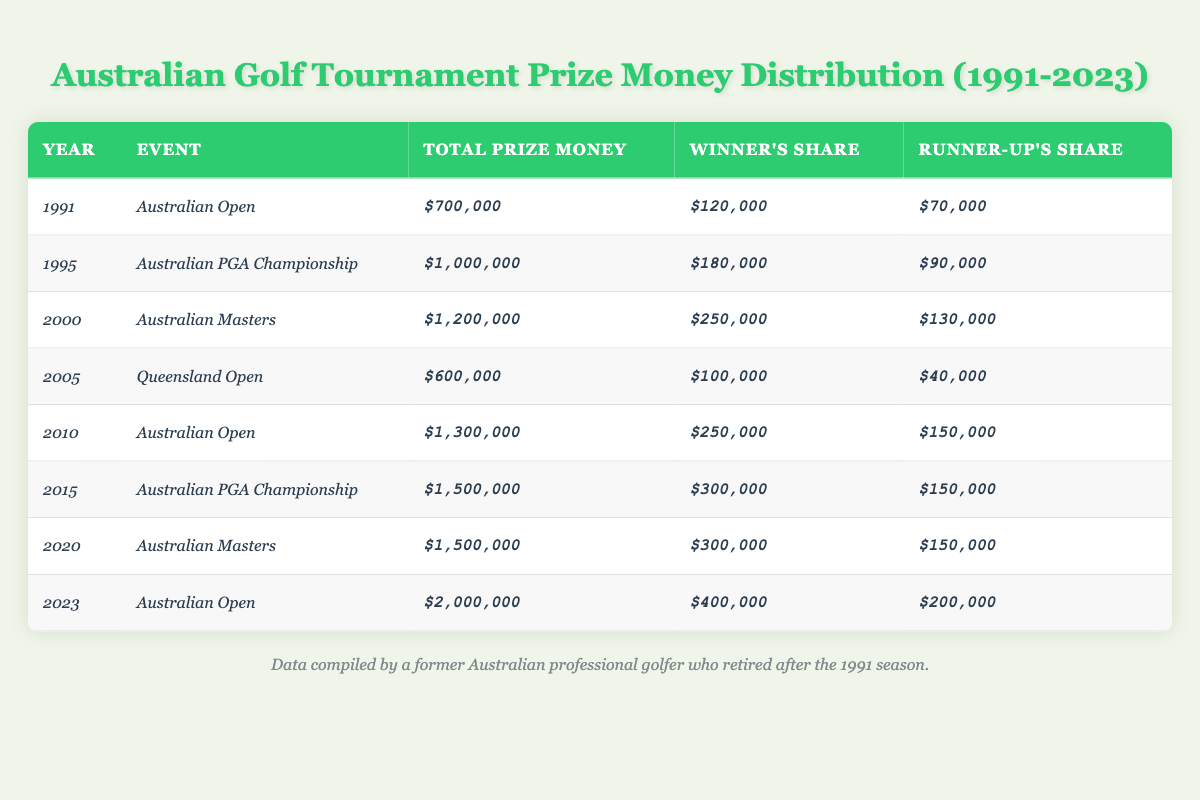What was the total prize money for the Australian Open in 2023? The table shows that the total prize money for the Australian Open in 2023 is $2,000,000.
Answer: $2,000,000 How much did the winner receive for the Australian Masters in 2000? According to the table, the winner's share for the Australian Masters in 2000 was $250,000.
Answer: $250,000 Which tournament had the highest total prize money and what was that amount? By comparing the total prize money across all tournaments, the Australian Open in 2023 had the highest total prize money of $2,000,000.
Answer: $2,000,000 Was there an increase in the winner's share from the Australian Open in 1991 to the one in 2023? The winner's share increased from $120,000 in 1991 to $400,000 in 2023, confirming that there was an increase.
Answer: Yes What is the difference in total prize money between the Australian PGA Championship in 1995 and the one in 2015? The total prize money for the Australian PGA Championship in 1995 was $1,000,000, and in 2015 it was $1,500,000. The difference is $1,500,000 - $1,000,000 = $500,000.
Answer: $500,000 What was the runner-up's share for the Queensland Open in 2005? The runner-up's share for the Queensland Open in 2005 is listed as $40,000 in the table.
Answer: $40,000 If you add all the winner's shares from the years 1991, 1995, and 2000, what is the total? The winner's shares from those years are $120,000 (1991) + $180,000 (1995) + $250,000 (2000) = $550,000.
Answer: $550,000 Was the total prize money for the Australian Masters the same in 2000 and 2020? The total prize money for the Australian Masters was $1,200,000 in 2000 and $1,500,000 in 2020, indicating they were not the same.
Answer: No What is the average winner's share across all the listed tournaments from 1991 to 2023? Adding all the winner's shares ($120,000 + $180,000 + $250,000 + $100,000 + $250,000 + $300,000 + $300,000 + $400,000) gives a total of $1,600,000. There are 8 tournaments, so the average is $1,600,000 / 8 = $200,000.
Answer: $200,000 How much did the runner-up receive in the 2010 Australian Open? The runner-up's share for the 2010 Australian Open is specified as $150,000 in the table.
Answer: $150,000 